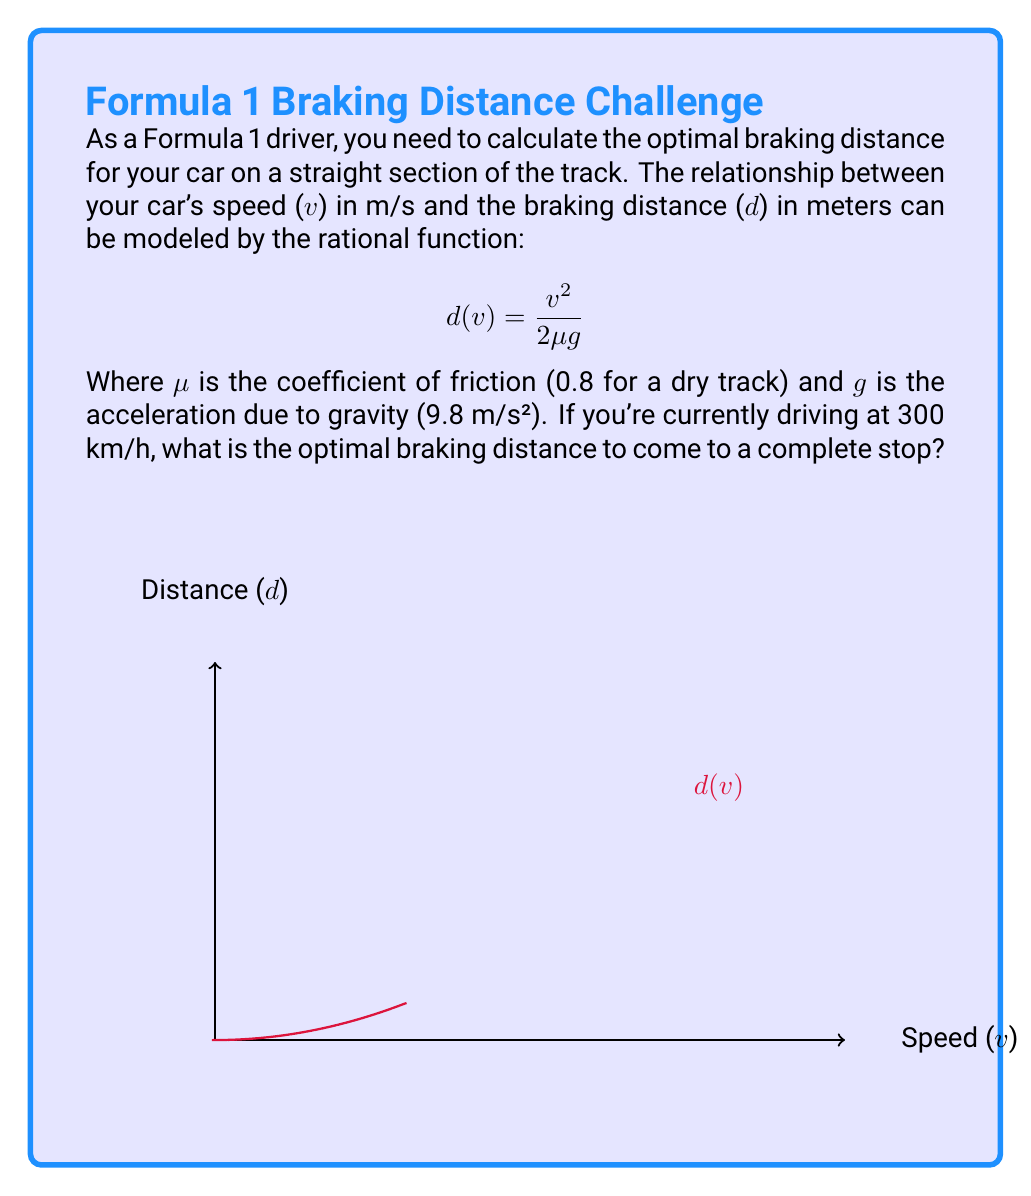Solve this math problem. Let's approach this step-by-step:

1) First, we need to convert the given speed from km/h to m/s:
   $$300 \text{ km/h} = 300 \cdot \frac{1000 \text{ m}}{3600 \text{ s}} = 83.33 \text{ m/s}$$

2) Now we have all the values to plug into our rational function:
   - $v = 83.33 \text{ m/s}$
   - $\mu = 0.8$ (given for a dry track)
   - $g = 9.8 \text{ m/s}^2$

3) Let's substitute these values into our function:
   $$d(v) = \frac{v^2}{2\mu g}$$
   $$d(83.33) = \frac{(83.33)^2}{2(0.8)(9.8)}$$

4) Now let's calculate:
   $$d(83.33) = \frac{6943.89}{15.68} = 442.85 \text{ meters}$$

5) Rounding to the nearest meter:
   $$d(83.33) \approx 443 \text{ meters}$$

Therefore, the optimal braking distance for the Formula 1 car to come to a complete stop from 300 km/h is approximately 443 meters.
Answer: 443 meters 